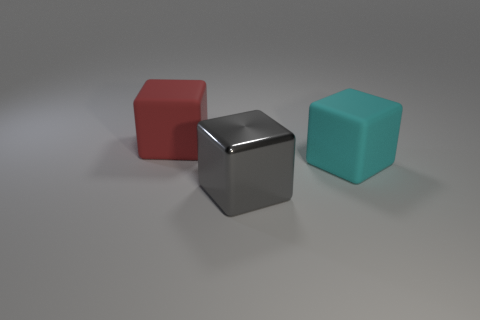Are there any other things that have the same material as the large gray thing?
Your answer should be very brief. No. There is a large gray object that is the same shape as the big red object; what is its material?
Your response must be concise. Metal. The big metal block has what color?
Make the answer very short. Gray. What color is the big matte object to the left of the matte thing that is to the right of the big red rubber cube?
Your answer should be very brief. Red. Do the big metal cube and the large rubber cube that is left of the big shiny thing have the same color?
Offer a very short reply. No. There is a gray cube to the right of the big matte cube that is on the left side of the big cyan cube; what number of red rubber cubes are in front of it?
Your answer should be compact. 0. Are there any blocks to the right of the big metallic cube?
Offer a very short reply. Yes. What number of blocks are tiny purple metallic things or big gray shiny objects?
Provide a short and direct response. 1. How many big objects are on the right side of the large red cube and behind the big gray thing?
Keep it short and to the point. 1. Are there the same number of matte objects behind the big cyan thing and large gray cubes that are behind the red rubber block?
Provide a short and direct response. No. 